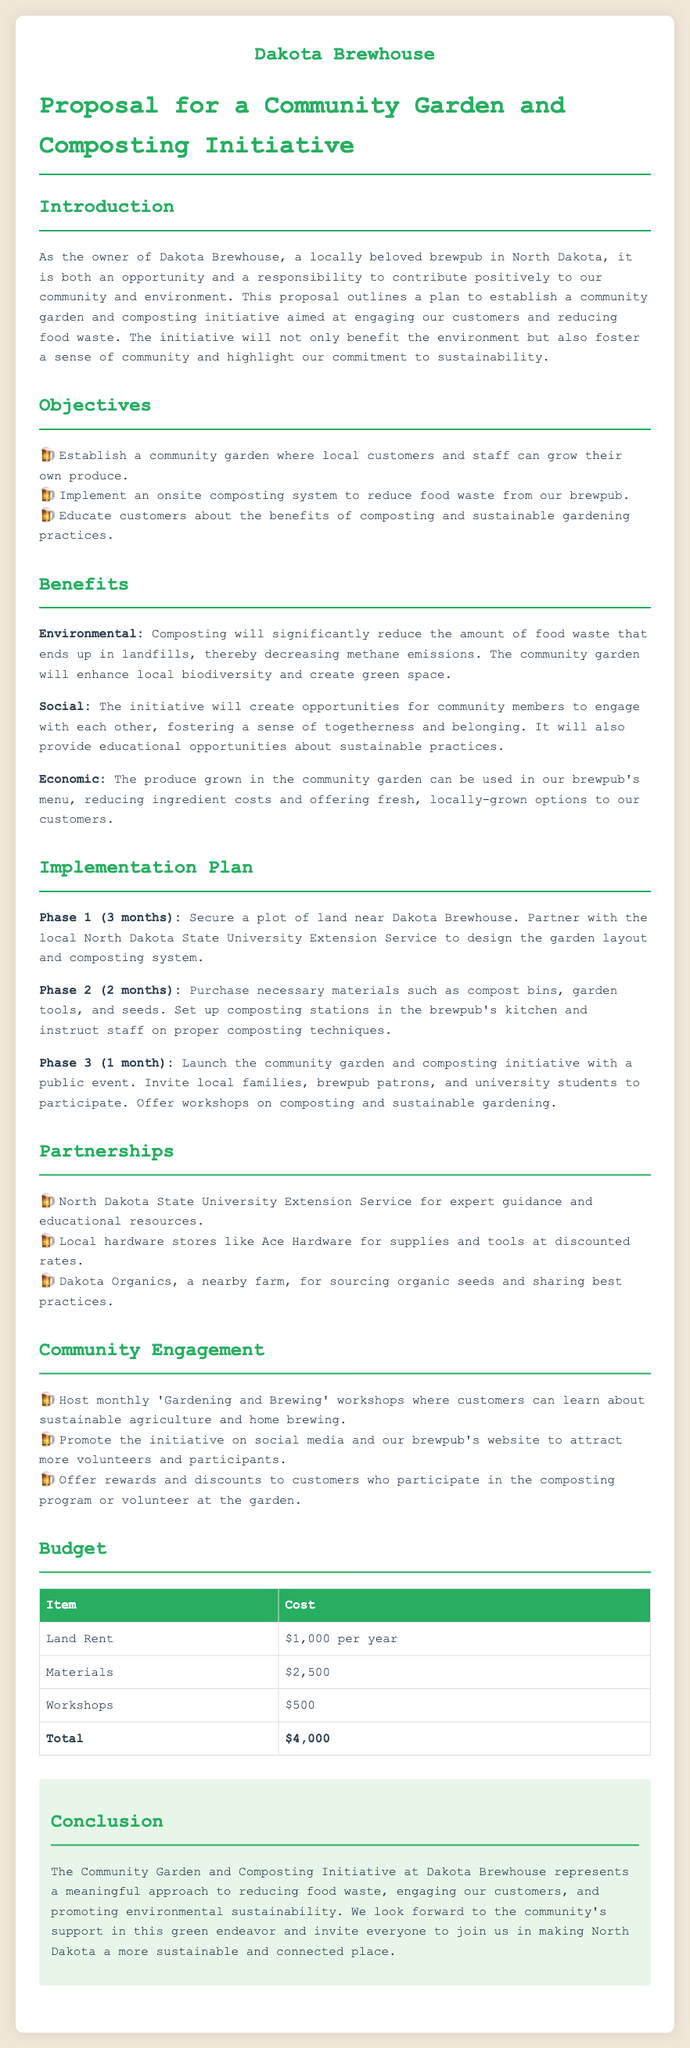what is the name of the brewpub? The name of the brewpub mentioned in the proposal is "Dakota Brewhouse."
Answer: Dakota Brewhouse how much will land rent cost per year? The document specifies that the cost for land rent is $1,000 per year.
Answer: $1,000 per year what is the total budget for the initiative? The total budget for the community garden and composting initiative is clearly stated in the document as $4,000.
Answer: $4,000 which university is mentioned as a partner? The North Dakota State University Extension Service is listed as a partner in the initiative.
Answer: North Dakota State University Extension Service what is one environmental benefit of composting mentioned in the document? The document states that composting will significantly reduce the amount of food waste that ends up in landfills, decreasing methane emissions.
Answer: Decreasing methane emissions how long is Phase 1 of the implementation plan? Phase 1 of the implementation plan is stated to take 3 months.
Answer: 3 months what type of workshops will be hosted monthly? The proposal indicates that "Gardening and Brewing" workshops will be hosted monthly.
Answer: Gardening and Brewing who will provide organic seeds for the initiative? The nearby farm, Dakota Organics, is mentioned as the source for organic seeds.
Answer: Dakota Organics 